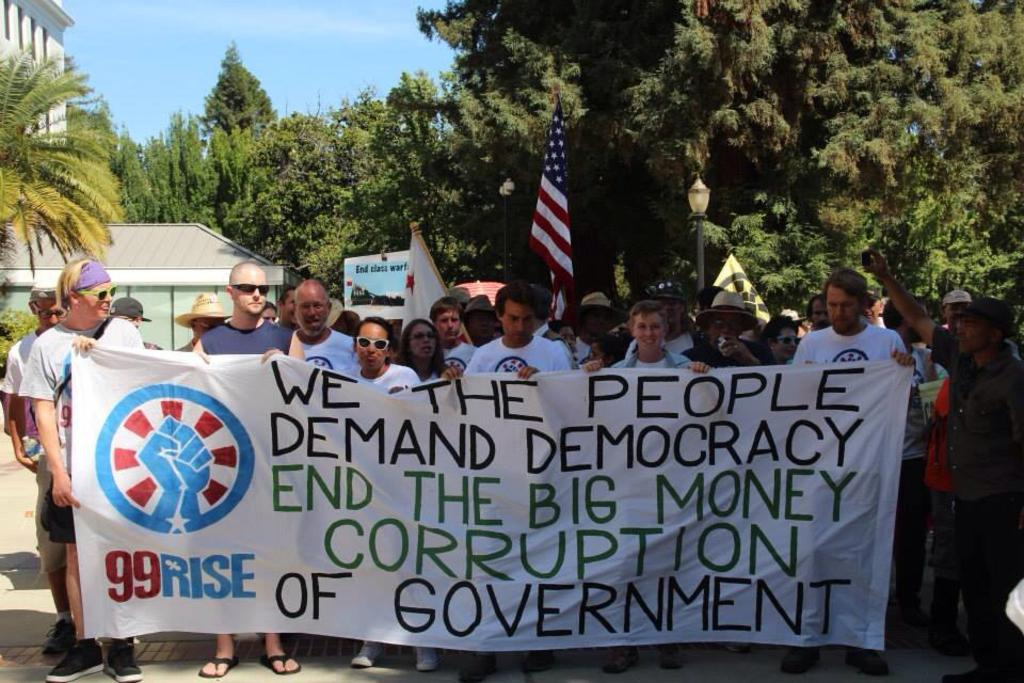What are the people in the image doing? The people in the image are standing and holding a banner. What else can be seen in the image besides the people? There is a flag and a building in the background of the image, as well as trees. Can you see any jellyfish swimming in the image? No, there are no jellyfish present in the image. What type of sticks are the people using to hold the banner? The image does not show any sticks being used to hold the banner; the people are simply holding it with their hands. 